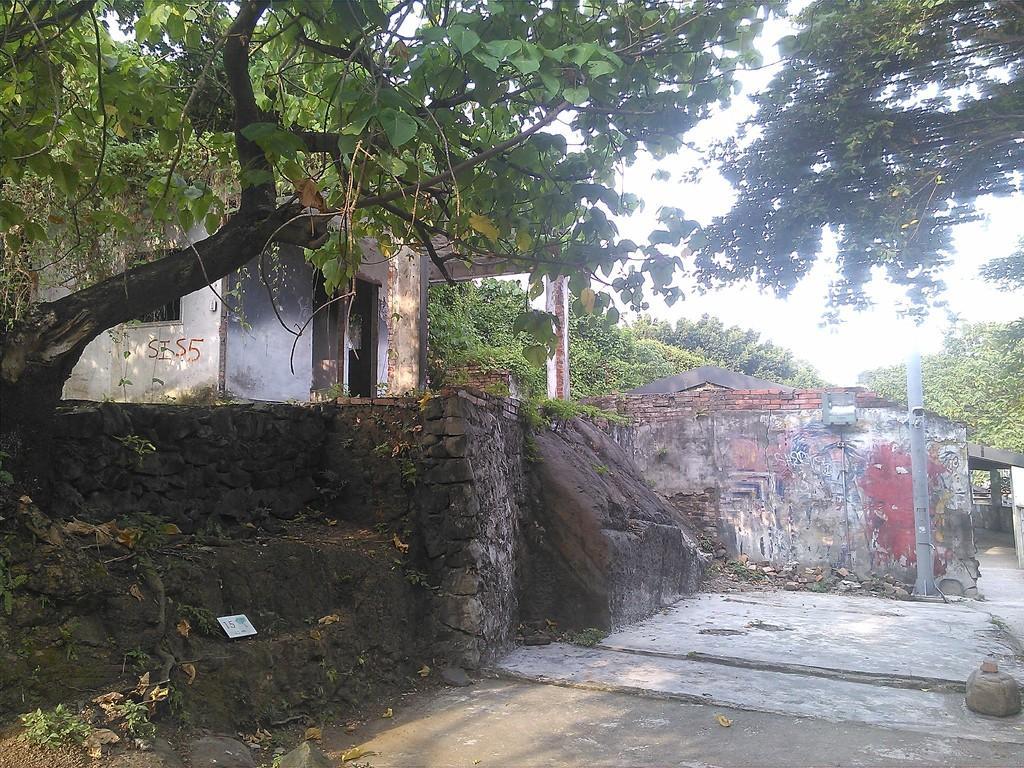Please provide a concise description of this image. There are trees, houses, a pole and other trees at the back. 